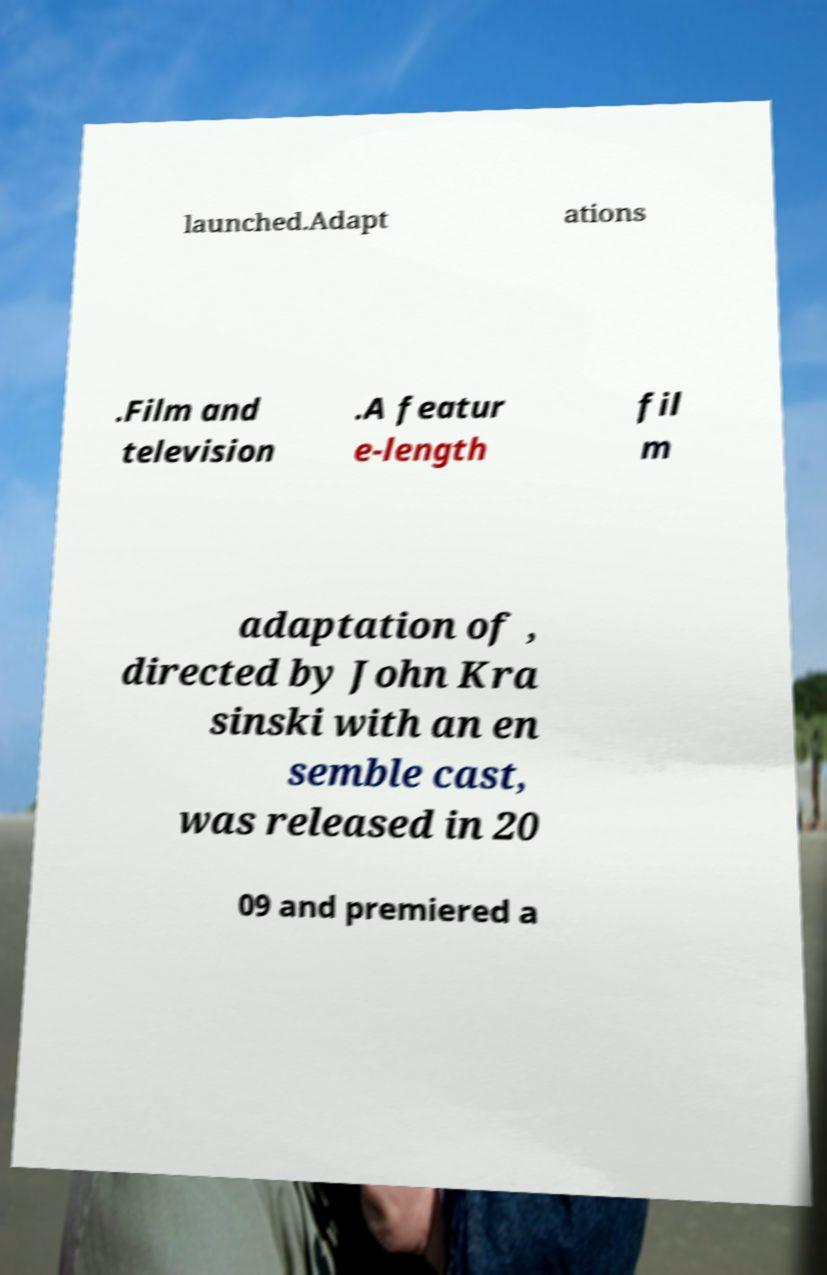Please read and relay the text visible in this image. What does it say? launched.Adapt ations .Film and television .A featur e-length fil m adaptation of , directed by John Kra sinski with an en semble cast, was released in 20 09 and premiered a 